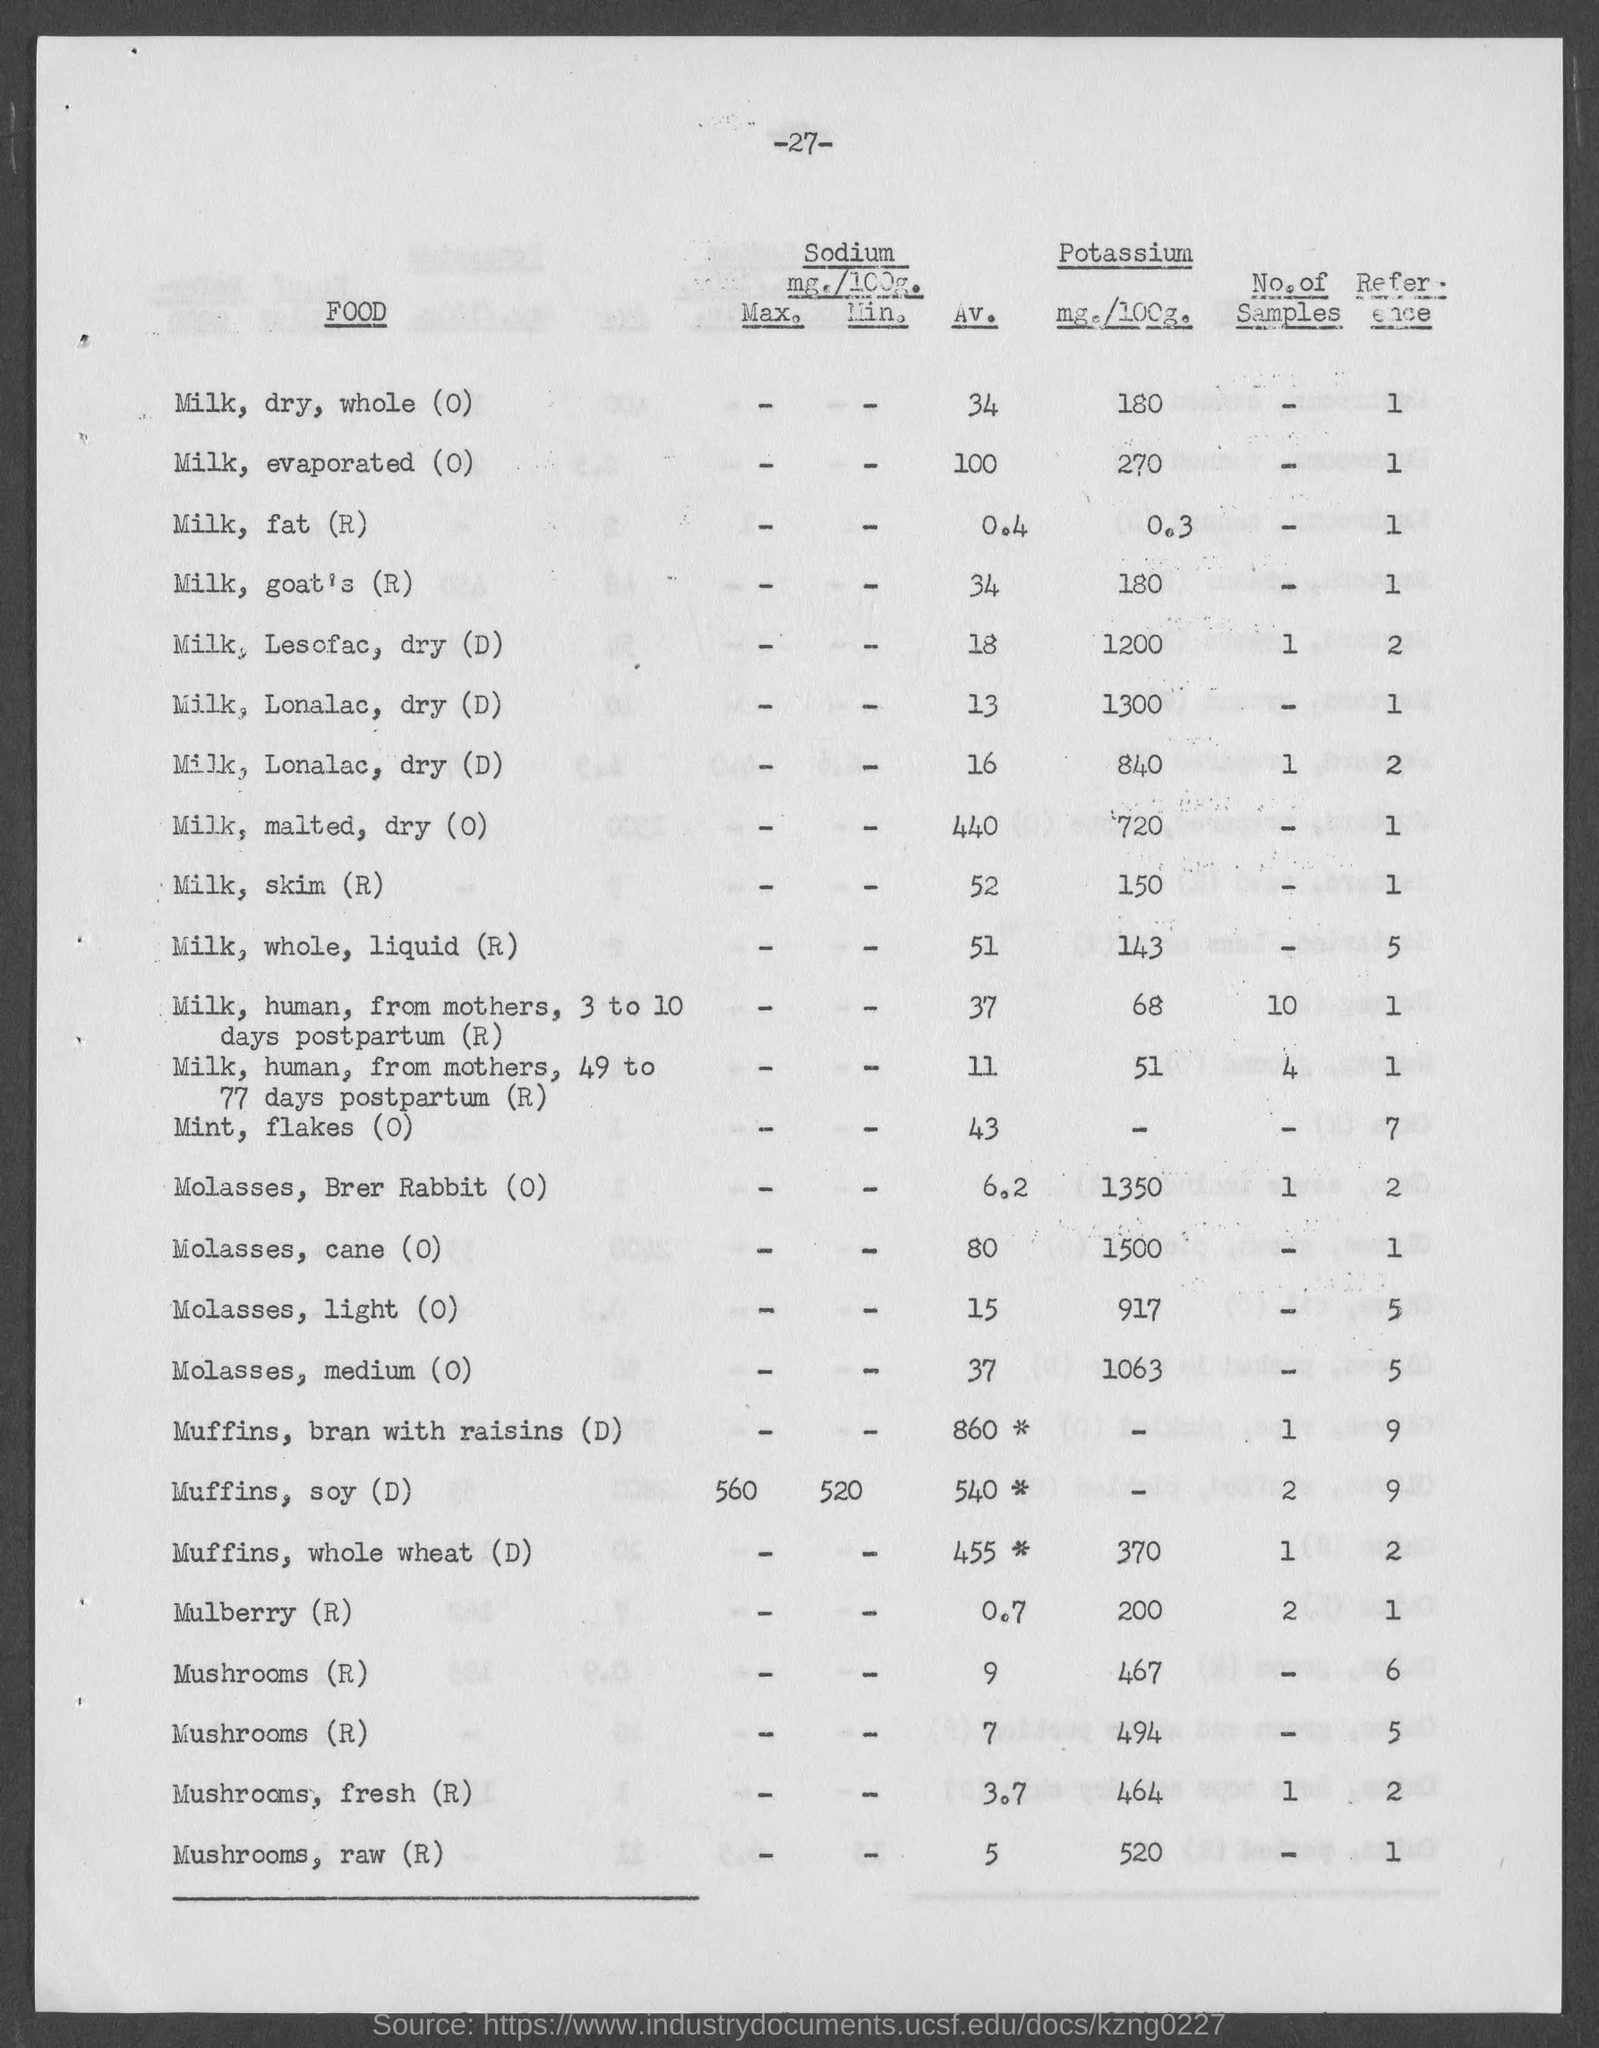What is the page number?
Offer a terse response. -27-. What is the number of samples of Mushrooms, fresh (R)?
Give a very brief answer. 1. What is the number of samples of Muffins, soy (D)?
Keep it short and to the point. 2. 